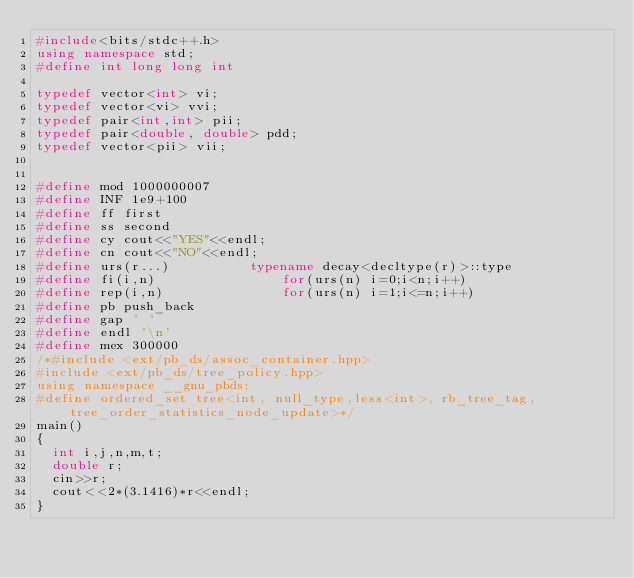<code> <loc_0><loc_0><loc_500><loc_500><_C++_>#include<bits/stdc++.h>
using namespace std;
#define int long long int

typedef vector<int> vi;
typedef vector<vi> vvi;
typedef pair<int,int> pii;
typedef pair<double, double> pdd;
typedef vector<pii> vii;


#define mod 1000000007
#define INF 1e9+100
#define ff first
#define ss second
#define cy cout<<"YES"<<endl;
#define cn cout<<"NO"<<endl;
#define urs(r...)          typename decay<decltype(r)>::type
#define fi(i,n)                for(urs(n) i=0;i<n;i++)
#define rep(i,n)               for(urs(n) i=1;i<=n;i++)
#define pb push_back
#define gap ' '
#define endl '\n'
#define mex 300000
/*#include <ext/pb_ds/assoc_container.hpp>
#include <ext/pb_ds/tree_policy.hpp>
using namespace __gnu_pbds;
#define ordered_set tree<int, null_type,less<int>, rb_tree_tag,tree_order_statistics_node_update>*/
main()
{
	int i,j,n,m,t;
	double r;
	cin>>r;
	cout<<2*(3.1416)*r<<endl;
}
</code> 